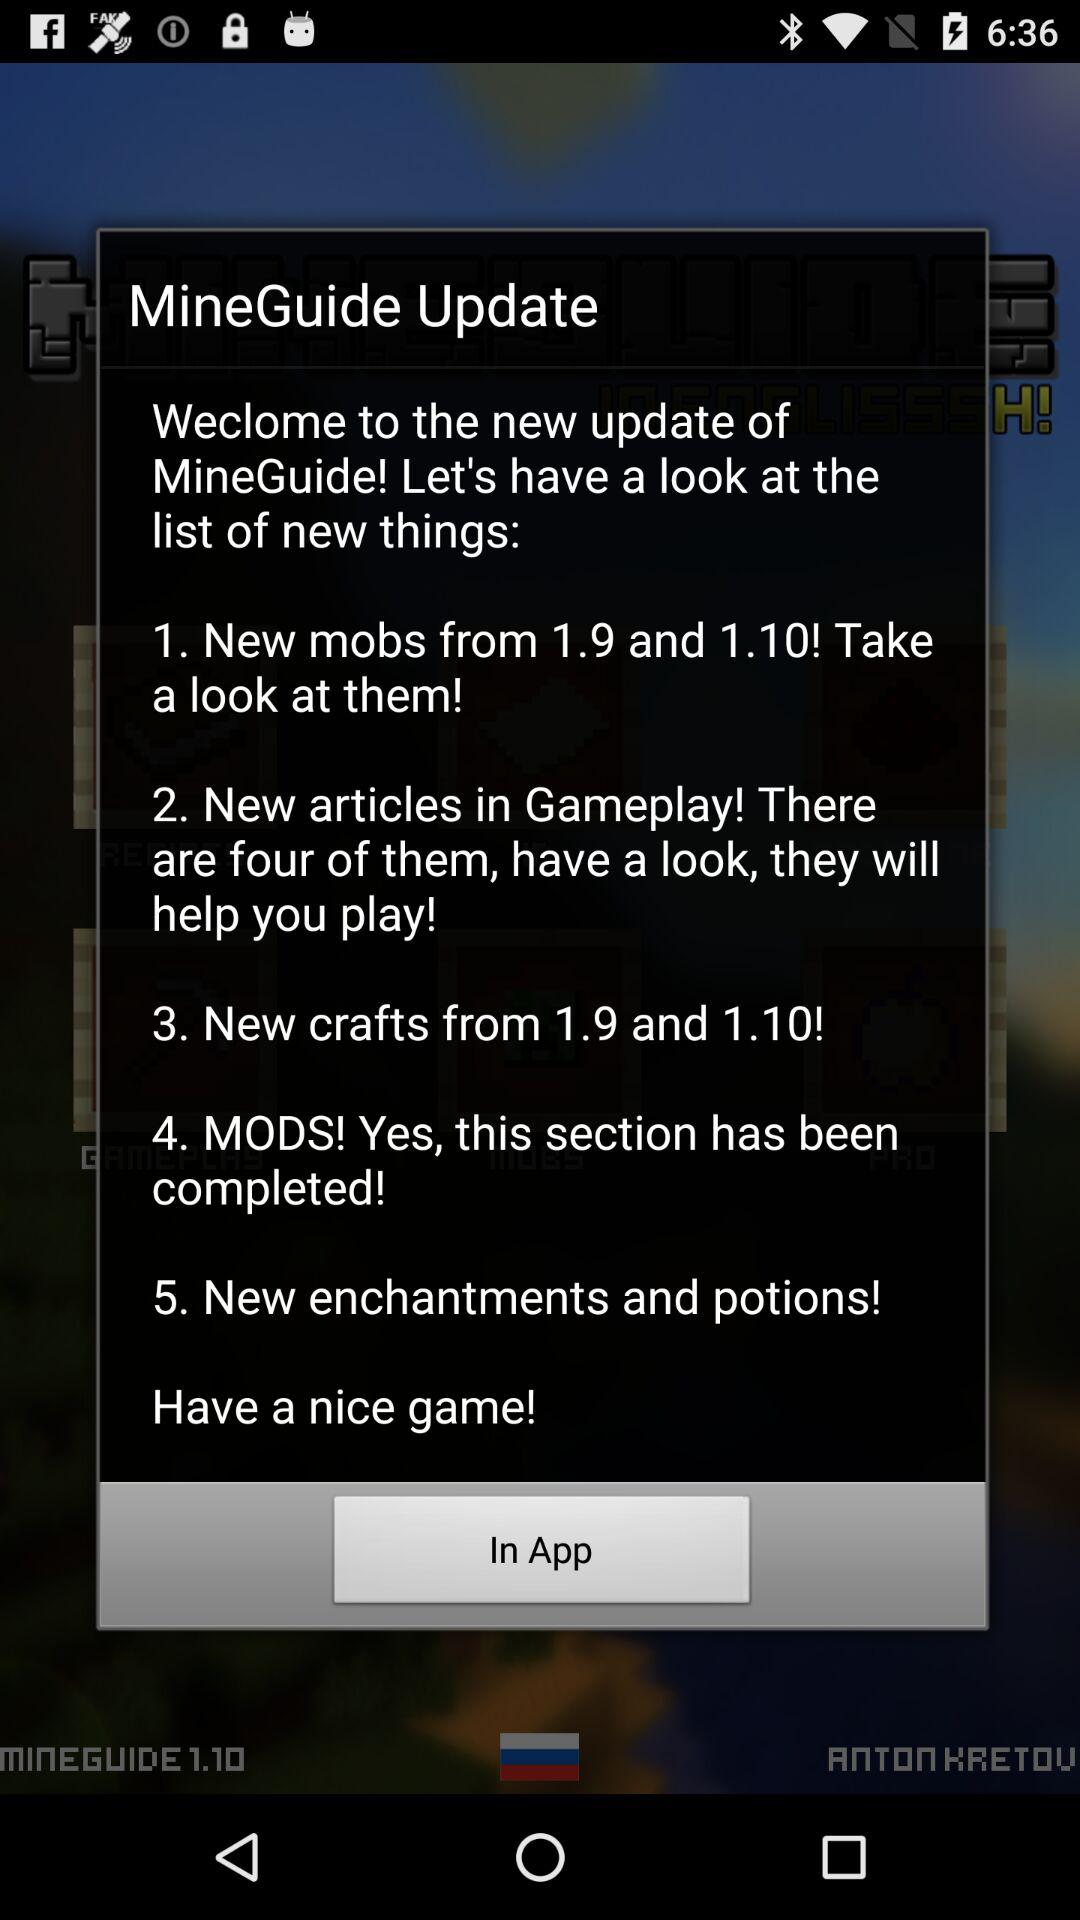How many new sections are there in the update?
Answer the question using a single word or phrase. 5 